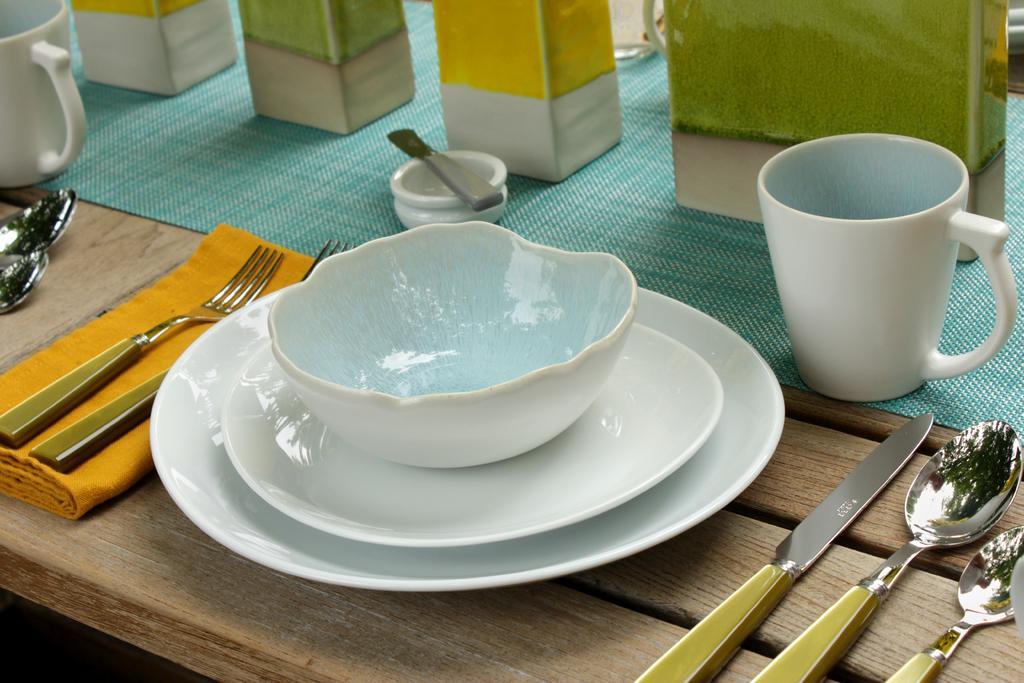How would you summarize this image in a sentence or two? In this image i can see a bowl,few plates, a mug, a spoon, a knife on a table. 